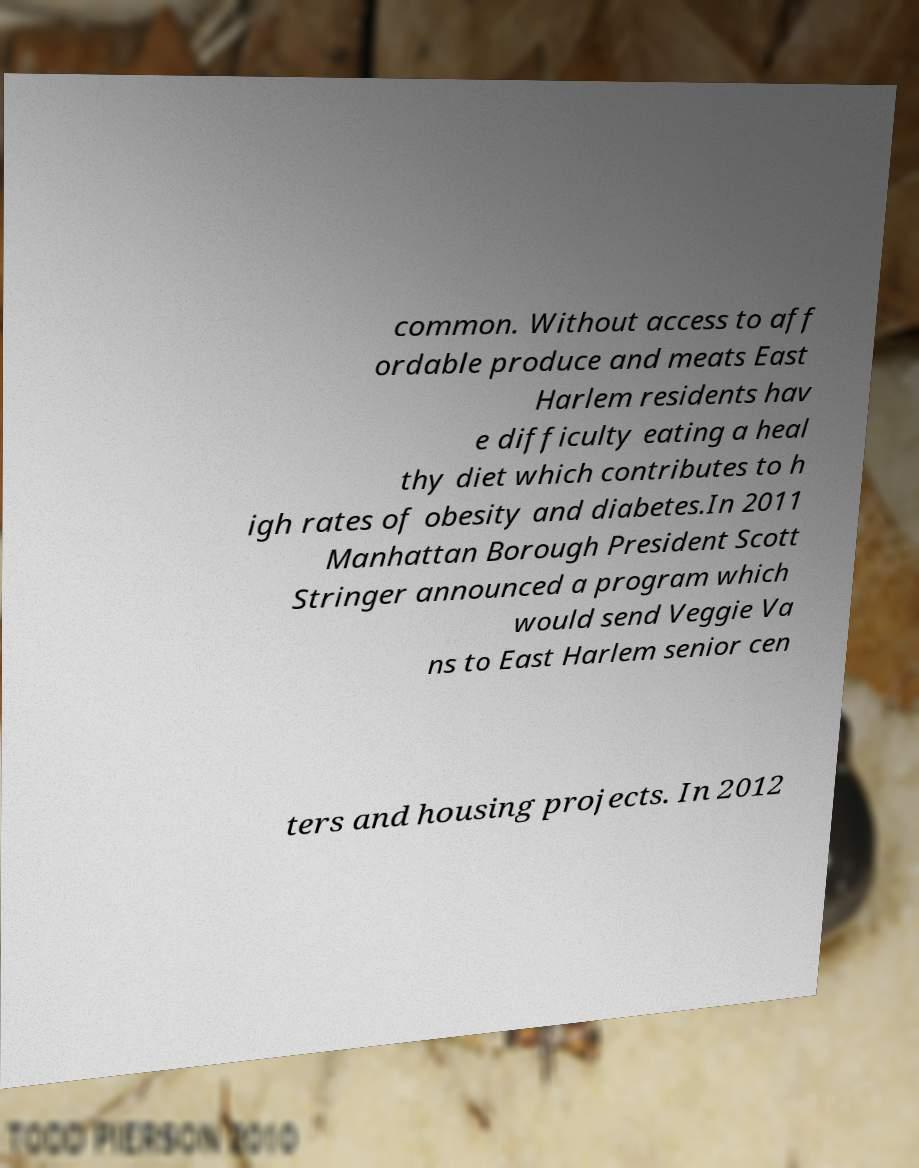Can you read and provide the text displayed in the image?This photo seems to have some interesting text. Can you extract and type it out for me? common. Without access to aff ordable produce and meats East Harlem residents hav e difficulty eating a heal thy diet which contributes to h igh rates of obesity and diabetes.In 2011 Manhattan Borough President Scott Stringer announced a program which would send Veggie Va ns to East Harlem senior cen ters and housing projects. In 2012 